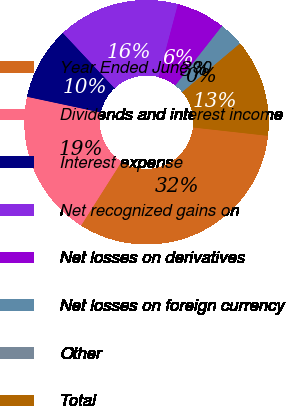Convert chart to OTSL. <chart><loc_0><loc_0><loc_500><loc_500><pie_chart><fcel>Year Ended June 30<fcel>Dividends and interest income<fcel>Interest expense<fcel>Net recognized gains on<fcel>Net losses on derivatives<fcel>Net losses on foreign currency<fcel>Other<fcel>Total<nl><fcel>32.23%<fcel>19.35%<fcel>9.68%<fcel>16.12%<fcel>6.46%<fcel>3.24%<fcel>0.02%<fcel>12.9%<nl></chart> 